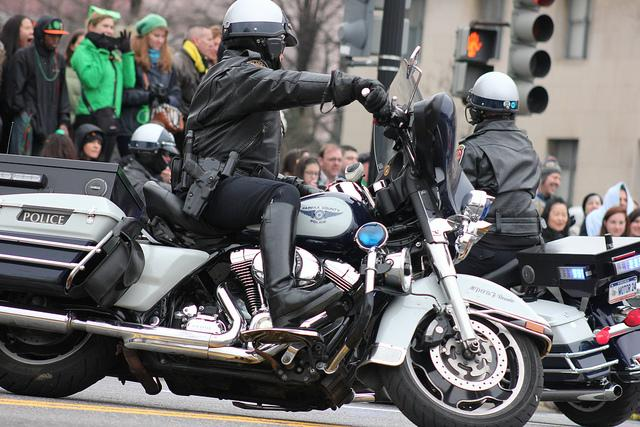Ignoring everything else about the image what should pedestrians do about crossing the street according to the traffic light? Please explain your reasoning. wait. People will wait. 